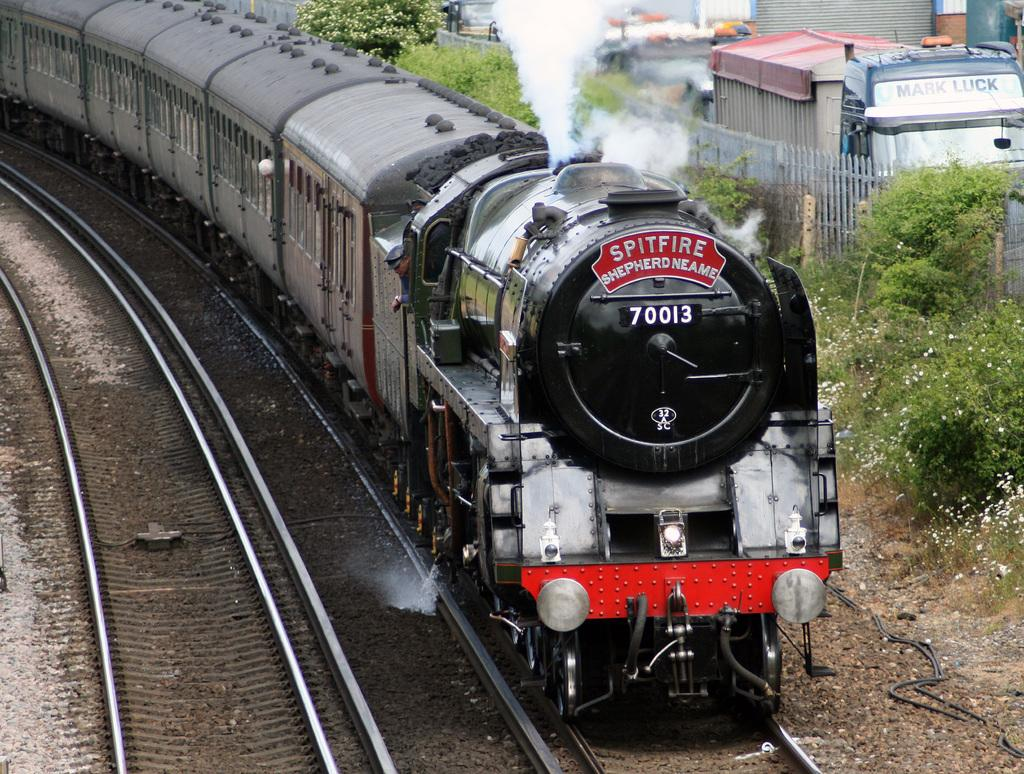<image>
Create a compact narrative representing the image presented. A train has the number 70013 and the name Spitfire on it. 